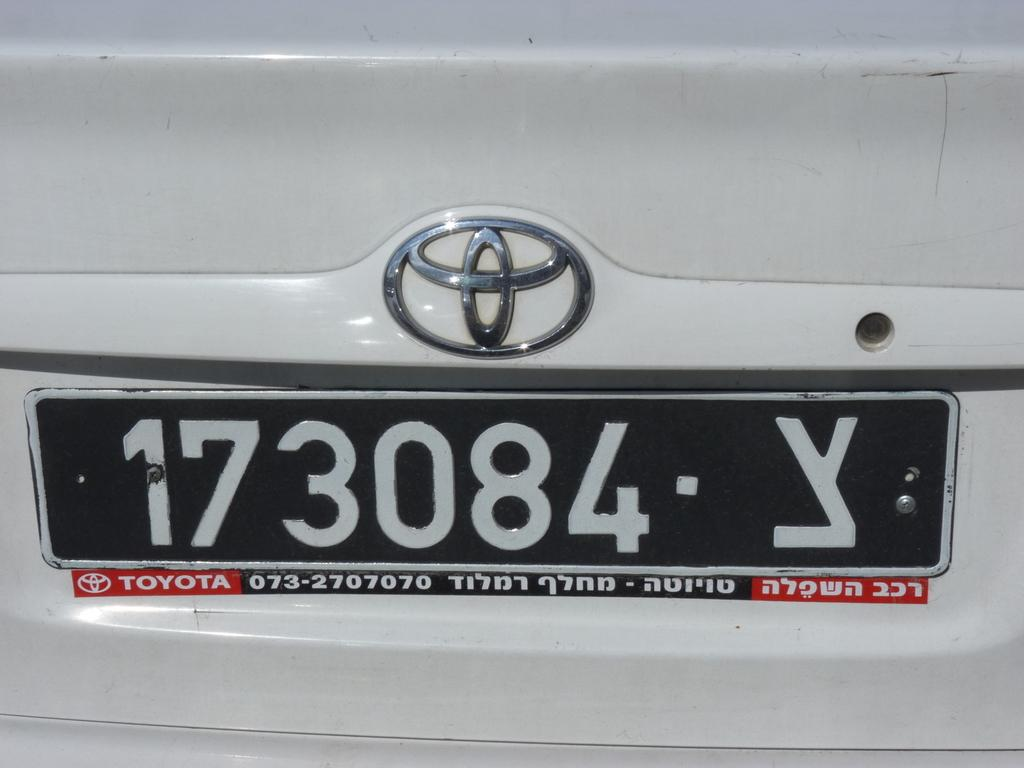<image>
Create a compact narrative representing the image presented. The boot of a white Toyota car, the number plate reads 1730084 Y. 